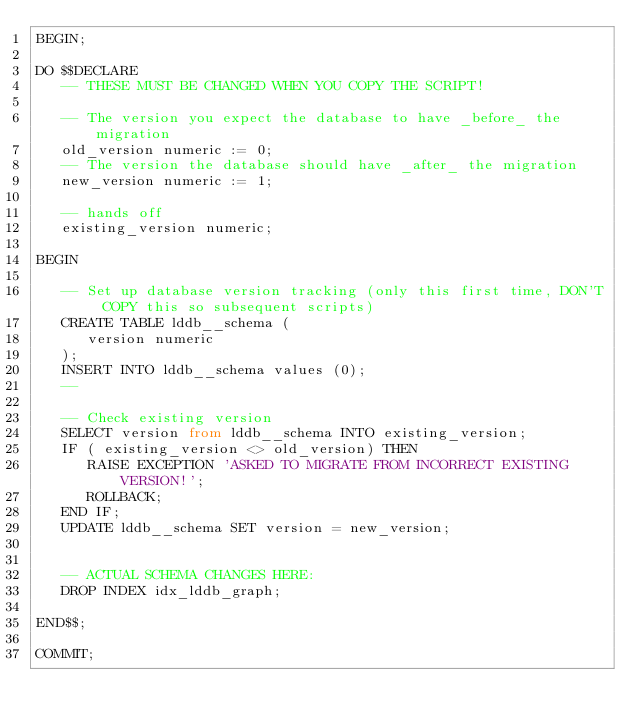Convert code to text. <code><loc_0><loc_0><loc_500><loc_500><_SQL_>BEGIN;

DO $$DECLARE
   -- THESE MUST BE CHANGED WHEN YOU COPY THE SCRIPT!
   
   -- The version you expect the database to have _before_ the migration
   old_version numeric := 0;
   -- The version the database should have _after_ the migration
   new_version numeric := 1;

   -- hands off
   existing_version numeric;

BEGIN

   -- Set up database version tracking (only this first time, DON'T COPY this so subsequent scripts)
   CREATE TABLE lddb__schema (
      version numeric
   );
   INSERT INTO lddb__schema values (0);
   --

   -- Check existing version
   SELECT version from lddb__schema INTO existing_version;
   IF ( existing_version <> old_version) THEN
      RAISE EXCEPTION 'ASKED TO MIGRATE FROM INCORRECT EXISTING VERSION!';
      ROLLBACK;
   END IF;
   UPDATE lddb__schema SET version = new_version;


   -- ACTUAL SCHEMA CHANGES HERE:
   DROP INDEX idx_lddb_graph;

END$$;

COMMIT;
</code> 